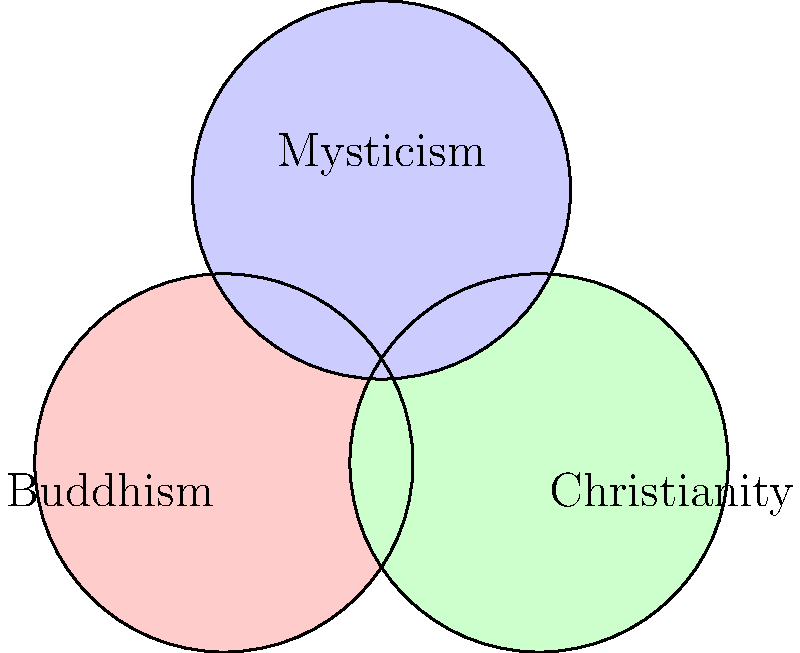In the Venn diagram above, three circles represent different belief systems: Buddhism, Christianity, and Mysticism. Each circle has a radius of 0.6 units. Calculate the area of the region where all three belief systems overlap (the center area common to all three circles). Express your answer in terms of π and round to three decimal places. To solve this problem, we'll follow these steps:

1) First, we need to understand that the centers of the circles form an equilateral triangle. The side length of this triangle is 1 unit (given by the distance between circle centers).

2) The area of overlap for three circles can be calculated using the formula:

   $$A = 3r^2 \arccos(\frac{d}{2r}) - \frac{\sqrt{3}}{4}d^2$$

   Where $r$ is the radius of each circle and $d$ is the side length of the equilateral triangle formed by the circle centers.

3) We're given that $r = 0.6$ and $d = 1$. Let's substitute these values:

   $$A = 3(0.6)^2 \arccos(\frac{1}{2(0.6)}) - \frac{\sqrt{3}}{4}(1)^2$$

4) Simplify:
   $$A = 1.08 \arccos(\frac{5}{6}) - \frac{\sqrt{3}}{4}$$

5) Calculate:
   $$A \approx 1.08 (0.5899) - 0.4330$$
   $$A \approx 0.6371 - 0.4330$$
   $$A \approx 0.2041$$

6) This area is in square units. To express it in terms of π, we divide by π:

   $$\frac{0.2041}{\pi} \approx 0.065$$

Therefore, the area of overlap is approximately 0.065π square units.
Answer: 0.065π square units 